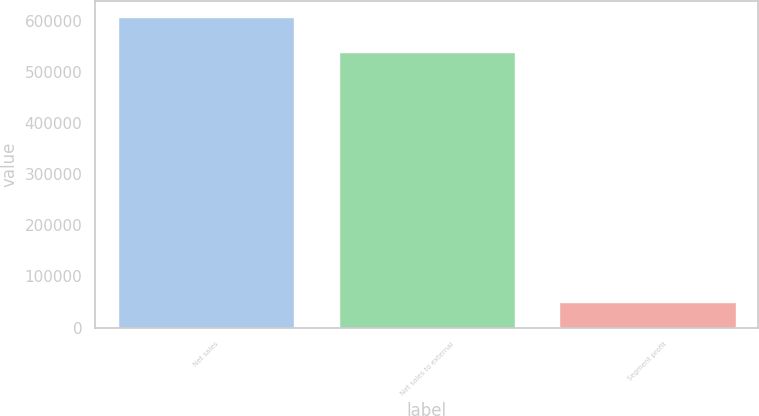Convert chart to OTSL. <chart><loc_0><loc_0><loc_500><loc_500><bar_chart><fcel>Net sales<fcel>Net sales to external<fcel>Segment profit<nl><fcel>607836<fcel>538953<fcel>50635<nl></chart> 